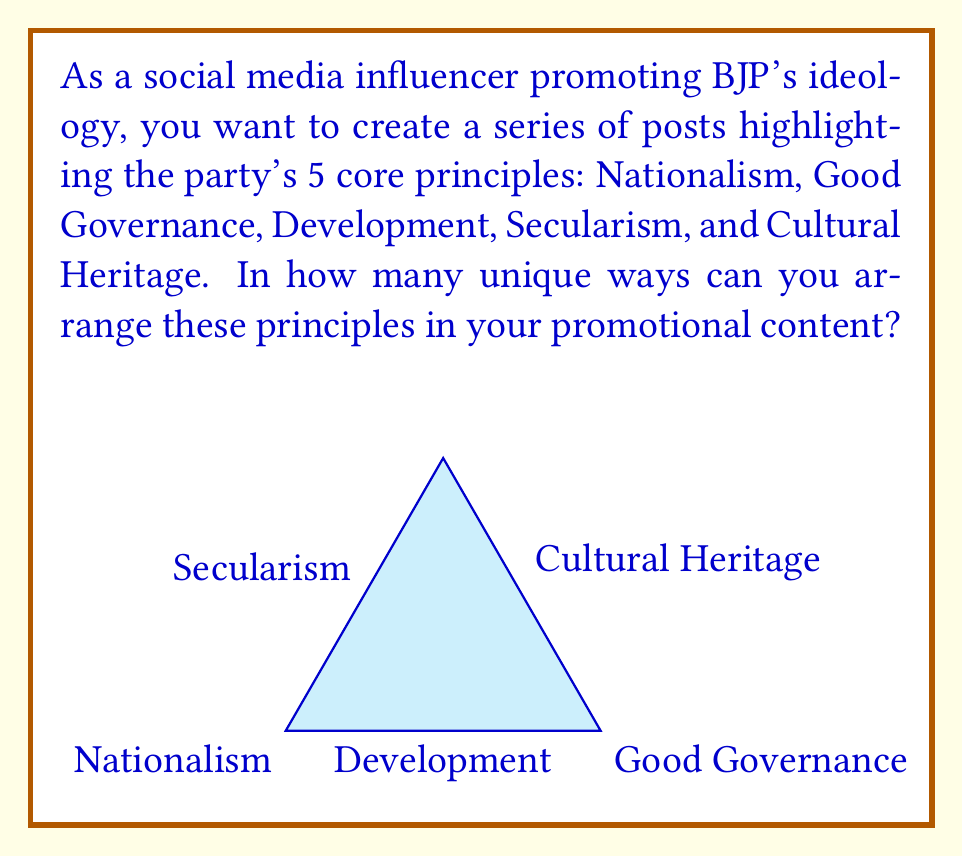Could you help me with this problem? To solve this problem, we need to use the concept of permutations. We are arranging 5 distinct principles, and the order matters.

1) The number of permutations of n distinct objects is given by the factorial of n, denoted as n!

2) In this case, n = 5 (for the 5 core principles of BJP)

3) Therefore, the number of unique arrangements is 5!

4) Let's calculate 5!:
   $$5! = 5 \times 4 \times 3 \times 2 \times 1 = 120$$

5) This means there are 120 unique ways to arrange the 5 core principles in your promotional content.

Each arrangement represents a different sequence of principles that could be used in your social media posts, allowing for variety in your messaging while consistently promoting BJP's ideology.
Answer: $120$ 